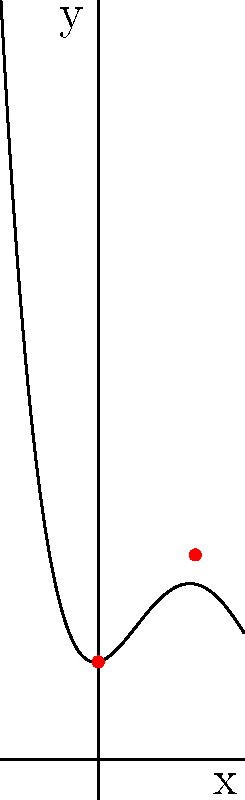As a distant relative of the royal family, you've been tasked with analyzing the silhouette of a historic crown. The curve of the crown's profile can be represented by the polynomial function $f(x) = ax^4 + bx^3 + cx^2 + dx + e$. Given that the curve passes through the points (0, 2) and (2, 4.2), and the coefficient of $x^4$ is 0.1, determine the values of $a$, $b$, $c$, $d$, and $e$. What is the sum of these coefficients? Let's approach this step-by-step:

1) We know that $a = 0.1$, so we need to find $b$, $c$, $d$, and $e$.

2) We can use the two given points to create equations:
   At (0, 2): $f(0) = e = 2$
   At (2, 4.2): $f(2) = 0.1(2^4) + b(2^3) + c(2^2) + d(2) + 2 = 4.2$

3) Simplify the second equation:
   $1.6 + 8b + 4c + 2d = 2.2$

4) We need two more equations. Let's use the fact that this is likely a smooth curve representing a crown. A common shape would have two peaks, which means the derivative would be zero at two points. Let's assume these are at $x = 0$ and $x = 2$:

   $f'(x) = 0.4x^3 + 3bx^2 + 2cx + d$
   
   At $x = 0$: $d = 0$
   At $x = 2$: $3.2 + 12b + 4c = 0$

5) Now we have a system of equations:
   $e = 2$
   $1.6 + 8b + 4c = 2.2$
   $3.2 + 12b + 4c = 0$

6) Subtracting the last equation from the second:
   $-1.6 - 4b = 2.2$
   $-4b = 3.8$
   $b = -0.95$

7) Substituting this back into the third equation:
   $3.2 - 11.4 + 4c = 0$
   $4c = 8.2$
   $c = 2.05$

8) Therefore, $a = 0.1$, $b = -0.95$, $c = 2.05$, $d = 0$, $e = 2$

9) The sum of these coefficients is:
   $0.1 + (-0.95) + 2.05 + 0 + 2 = 3.2$
Answer: 3.2 